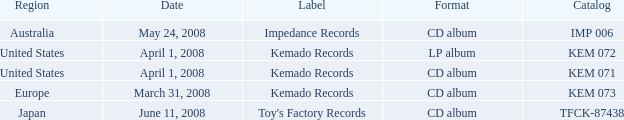Which Region has a Format of cd album, and a Label of kemado records, and a Catalog of kem 071? United States. 